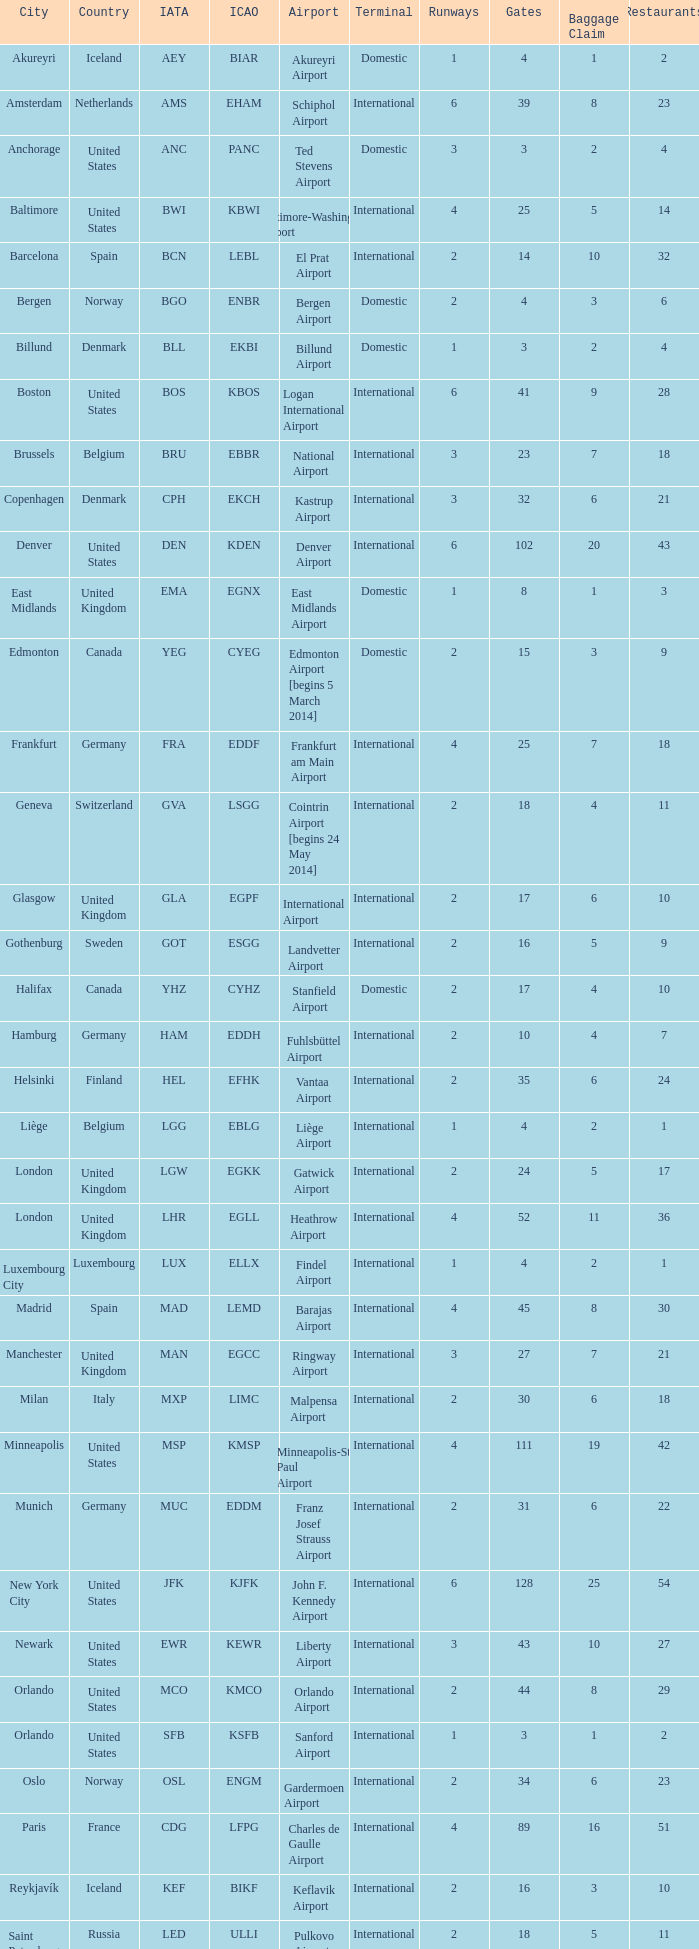What is the City with an IATA of MUC? Munich. Give me the full table as a dictionary. {'header': ['City', 'Country', 'IATA', 'ICAO', 'Airport', 'Terminal', 'Runways', 'Gates', 'Baggage Claim', 'Restaurants'], 'rows': [['Akureyri', 'Iceland', 'AEY', 'BIAR', 'Akureyri Airport', 'Domestic', '1', '4', '1', '2'], ['Amsterdam', 'Netherlands', 'AMS', 'EHAM', 'Schiphol Airport', 'International', '6', '39', '8', '23'], ['Anchorage', 'United States', 'ANC', 'PANC', 'Ted Stevens Airport', 'Domestic', '3', '3', '2', '4'], ['Baltimore', 'United States', 'BWI', 'KBWI', 'Baltimore-Washington Airport', 'International', '4', '25', '5', '14'], ['Barcelona', 'Spain', 'BCN', 'LEBL', 'El Prat Airport', 'International', '2', '14', '10', '32'], ['Bergen', 'Norway', 'BGO', 'ENBR', 'Bergen Airport', 'Domestic', '2', '4', '3', '6'], ['Billund', 'Denmark', 'BLL', 'EKBI', 'Billund Airport', 'Domestic', '1', '3', '2', '4'], ['Boston', 'United States', 'BOS', 'KBOS', 'Logan International Airport', 'International', '6', '41', '9', '28'], ['Brussels', 'Belgium', 'BRU', 'EBBR', 'National Airport', 'International', '3', '23', '7', '18'], ['Copenhagen', 'Denmark', 'CPH', 'EKCH', 'Kastrup Airport', 'International', '3', '32', '6', '21'], ['Denver', 'United States', 'DEN', 'KDEN', 'Denver Airport', 'International', '6', '102', '20', '43'], ['East Midlands', 'United Kingdom', 'EMA', 'EGNX', 'East Midlands Airport', 'Domestic', '1', '8', '1', '3'], ['Edmonton', 'Canada', 'YEG', 'CYEG', 'Edmonton Airport [begins 5 March 2014]', 'Domestic', '2', '15', '3', '9'], ['Frankfurt', 'Germany', 'FRA', 'EDDF', 'Frankfurt am Main Airport', 'International', '4', '25', '7', '18'], ['Geneva', 'Switzerland', 'GVA', 'LSGG', 'Cointrin Airport [begins 24 May 2014]', 'International', '2', '18', '4', '11'], ['Glasgow', 'United Kingdom', 'GLA', 'EGPF', 'International Airport', 'International', '2', '17', '6', '10'], ['Gothenburg', 'Sweden', 'GOT', 'ESGG', 'Landvetter Airport', 'International', '2', '16', '5', '9'], ['Halifax', 'Canada', 'YHZ', 'CYHZ', 'Stanfield Airport', 'Domestic', '2', '17', '4', '10'], ['Hamburg', 'Germany', 'HAM', 'EDDH', 'Fuhlsbüttel Airport', 'International', '2', '10', '4', '7'], ['Helsinki', 'Finland', 'HEL', 'EFHK', 'Vantaa Airport', 'International', '2', '35', '6', '24'], ['Liège', 'Belgium', 'LGG', 'EBLG', 'Liège Airport', 'International', '1', '4', '2', '1'], ['London', 'United Kingdom', 'LGW', 'EGKK', 'Gatwick Airport', 'International', '2', '24', '5', '17'], ['London', 'United Kingdom', 'LHR', 'EGLL', 'Heathrow Airport', 'International', '4', '52', '11', '36'], ['Luxembourg City', 'Luxembourg', 'LUX', 'ELLX', 'Findel Airport', 'International', '1', '4', '2', '1'], ['Madrid', 'Spain', 'MAD', 'LEMD', 'Barajas Airport', 'International', '4', '45', '8', '30'], ['Manchester', 'United Kingdom', 'MAN', 'EGCC', 'Ringway Airport', 'International', '3', '27', '7', '21'], ['Milan', 'Italy', 'MXP', 'LIMC', 'Malpensa Airport', 'International', '2', '30', '6', '18'], ['Minneapolis', 'United States', 'MSP', 'KMSP', 'Minneapolis-St Paul Airport', 'International', '4', '111', '19', '42'], ['Munich', 'Germany', 'MUC', 'EDDM', 'Franz Josef Strauss Airport', 'International', '2', '31', '6', '22'], ['New York City', 'United States', 'JFK', 'KJFK', 'John F. Kennedy Airport', 'International', '6', '128', '25', '54'], ['Newark', 'United States', 'EWR', 'KEWR', 'Liberty Airport', 'International', '3', '43', '10', '27'], ['Orlando', 'United States', 'MCO', 'KMCO', 'Orlando Airport', 'International', '2', '44', '8', '29'], ['Orlando', 'United States', 'SFB', 'KSFB', 'Sanford Airport', 'International', '1', '3', '1', '2'], ['Oslo', 'Norway', 'OSL', 'ENGM', 'Gardermoen Airport', 'International', '2', '34', '6', '23'], ['Paris', 'France', 'CDG', 'LFPG', 'Charles de Gaulle Airport', 'International', '4', '89', '16', '51'], ['Reykjavík', 'Iceland', 'KEF', 'BIKF', 'Keflavik Airport', 'International', '2', '16', '3', '10'], ['Saint Petersburg', 'Russia', 'LED', 'ULLI', 'Pulkovo Airport', 'International', '2', '18', '5', '11'], ['San Francisco', 'United States', 'SFO', 'KSFO', 'San Francisco Airport', 'International', '4', '103', '22', '41'], ['Seattle', 'United States', 'SEA', 'KSEA', 'Seattle–Tacoma Airport', 'International', '3', '80', '16', '34'], ['Stavanger', 'Norway', 'SVG', 'ENZV', 'Sola Airport', 'Domestic', '1', '7', '1', '3'], ['Stockholm', 'Sweden', 'ARN', 'ESSA', 'Arlanda Airport', 'International', '4', '60', '10', '34'], ['Toronto', 'Canada', 'YYZ', 'CYYZ', 'Pearson Airport', 'International', '5', '173', '34', '71'], ['Trondheim', 'Norway', 'TRD', 'ENVA', 'Trondheim Airport', 'Domestic', '1', '6', '1', '2'], ['Vancouver', 'Canada', 'YVR', 'CYVR', 'Vancouver Airport [begins 13 May 2014]', 'International', '4', '67', '12', '41'], ['Washington, D.C.', 'United States', 'IAD', 'KIAD', 'Dulles Airport', 'International', '3', '52', '10', '27'], ['Zurich', 'Switzerland', 'ZRH', 'LSZH', 'Kloten Airport', 'International', '3', '52', '10', '27']]} 